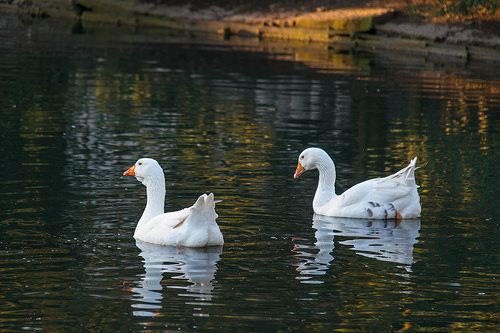<image>
Can you confirm if the duck is on the water? Yes. Looking at the image, I can see the duck is positioned on top of the water, with the water providing support. Is the goose to the left of the goose? Yes. From this viewpoint, the goose is positioned to the left side relative to the goose. 